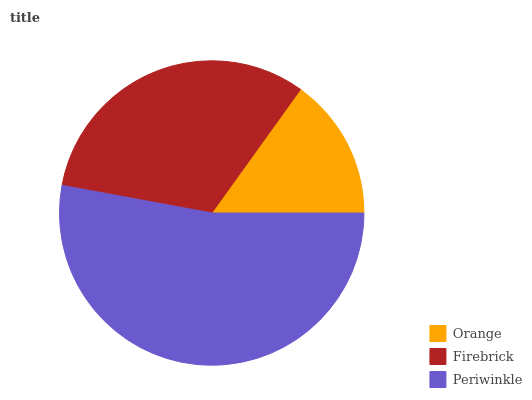Is Orange the minimum?
Answer yes or no. Yes. Is Periwinkle the maximum?
Answer yes or no. Yes. Is Firebrick the minimum?
Answer yes or no. No. Is Firebrick the maximum?
Answer yes or no. No. Is Firebrick greater than Orange?
Answer yes or no. Yes. Is Orange less than Firebrick?
Answer yes or no. Yes. Is Orange greater than Firebrick?
Answer yes or no. No. Is Firebrick less than Orange?
Answer yes or no. No. Is Firebrick the high median?
Answer yes or no. Yes. Is Firebrick the low median?
Answer yes or no. Yes. Is Orange the high median?
Answer yes or no. No. Is Periwinkle the low median?
Answer yes or no. No. 